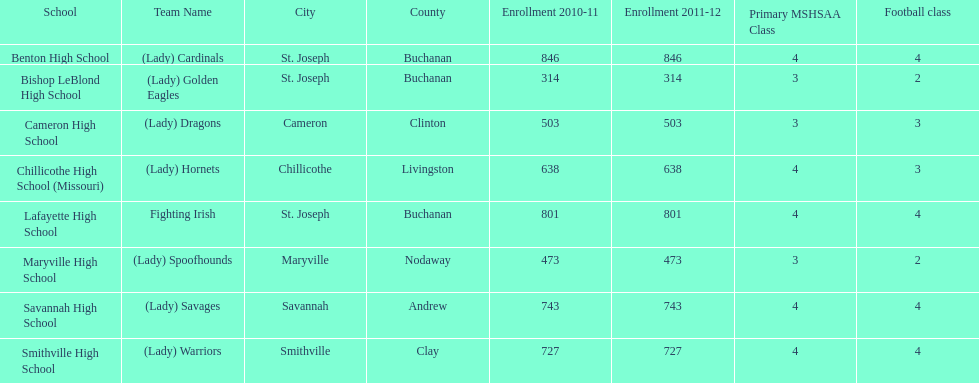Which school has the largest enrollment? Benton High School. 